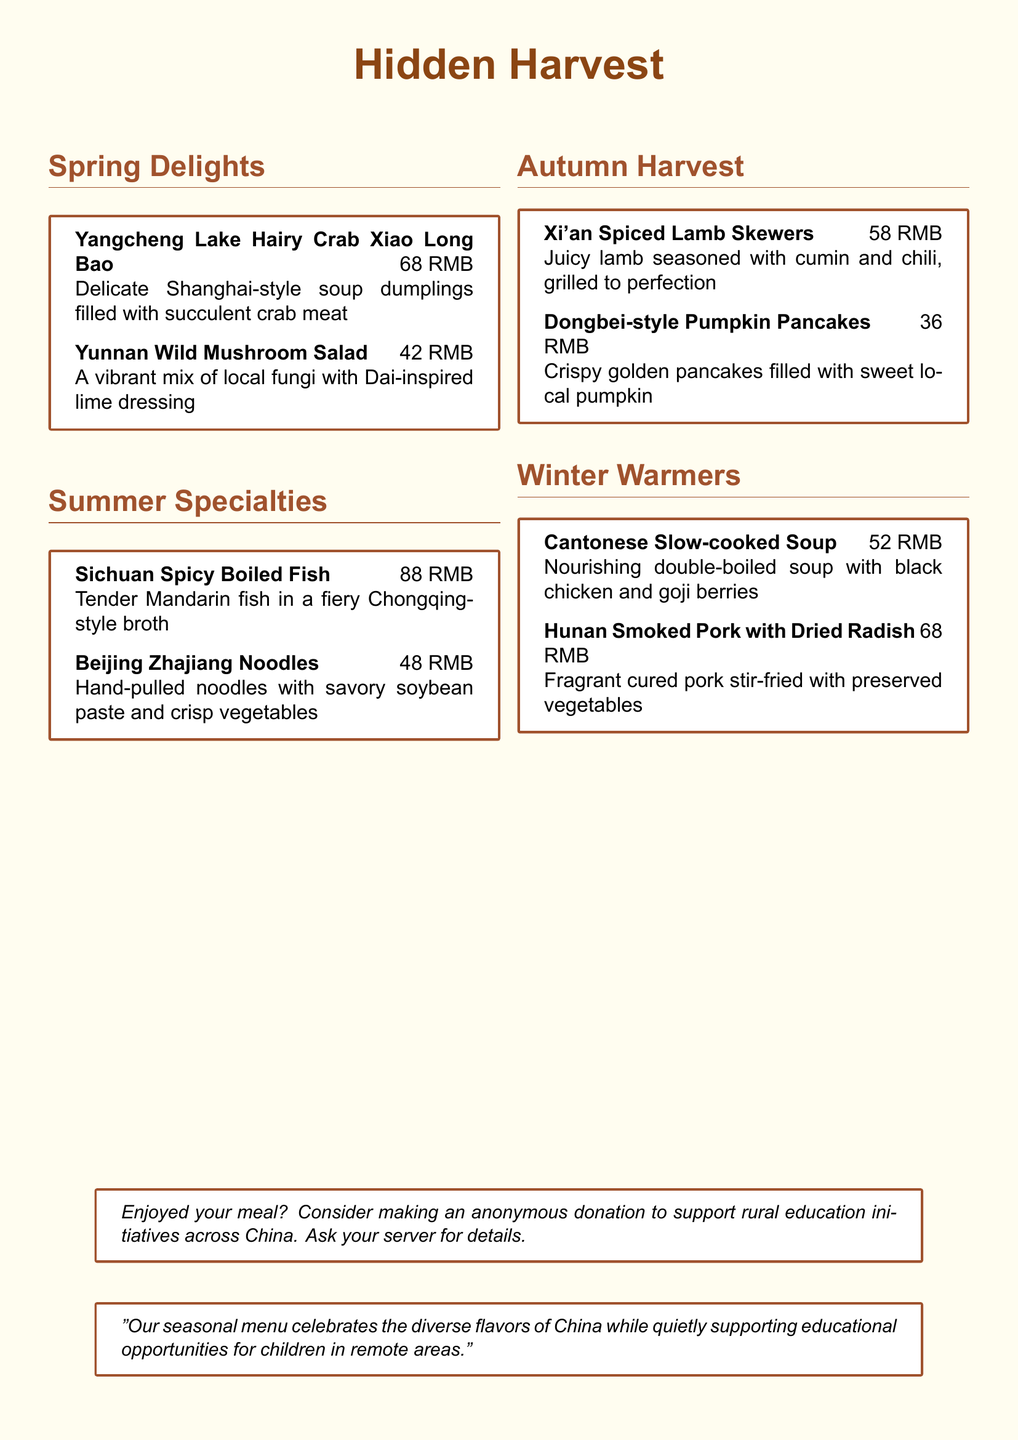what is the name of the restaurant? The restaurant is called "Hidden Harvest" as stated in the document title.
Answer: Hidden Harvest what is the price of Yangcheng Lake Hairy Crab Xiao Long Bao? The price for this dish is listed as 68 RMB.
Answer: 68 RMB which region inspires the Yunnan Wild Mushroom Salad? The salad is inspired by Dai cuisine from the Yunnan region.
Answer: Dai how much does the Winter Warmers section feature dishes for? The prices for the dishes in the Winter Warmers section are 52 RMB and 68 RMB, totaling 120 RMB.
Answer: 120 RMB what dish contains black chicken and goji berries? The dish is the Cantonese Slow-cooked Soup which features these ingredients.
Answer: Cantonese Slow-cooked Soup how many dishes are featured in the Spring Delights section? There are two dishes listed in the Spring Delights section.
Answer: Two what type of donation does the menu encourage? The menu encourages making anonymous donations for rural education initiatives.
Answer: Anonymous donations which season features Xi'an Spiced Lamb Skewers? This dish is part of the Autumn Harvest section of the menu.
Answer: Autumn Harvest what is the unique aspect of the restaurant's seasonal menu? The seasonal menu showcases dishes inspired by different regions of China.
Answer: Different regions of China 